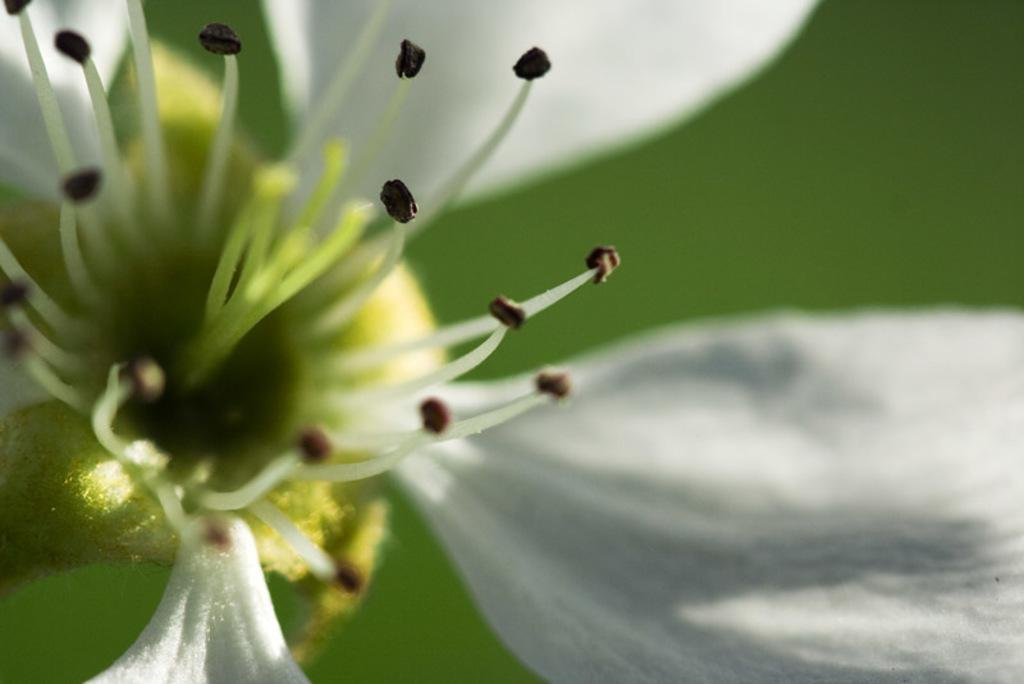What is the main subject of the image? There is a flower in the image. What color is the background of the image? The background of the image is green. What type of rhythm can be heard coming from the flower in the image? There is no sound or rhythm associated with the flower in the image. 